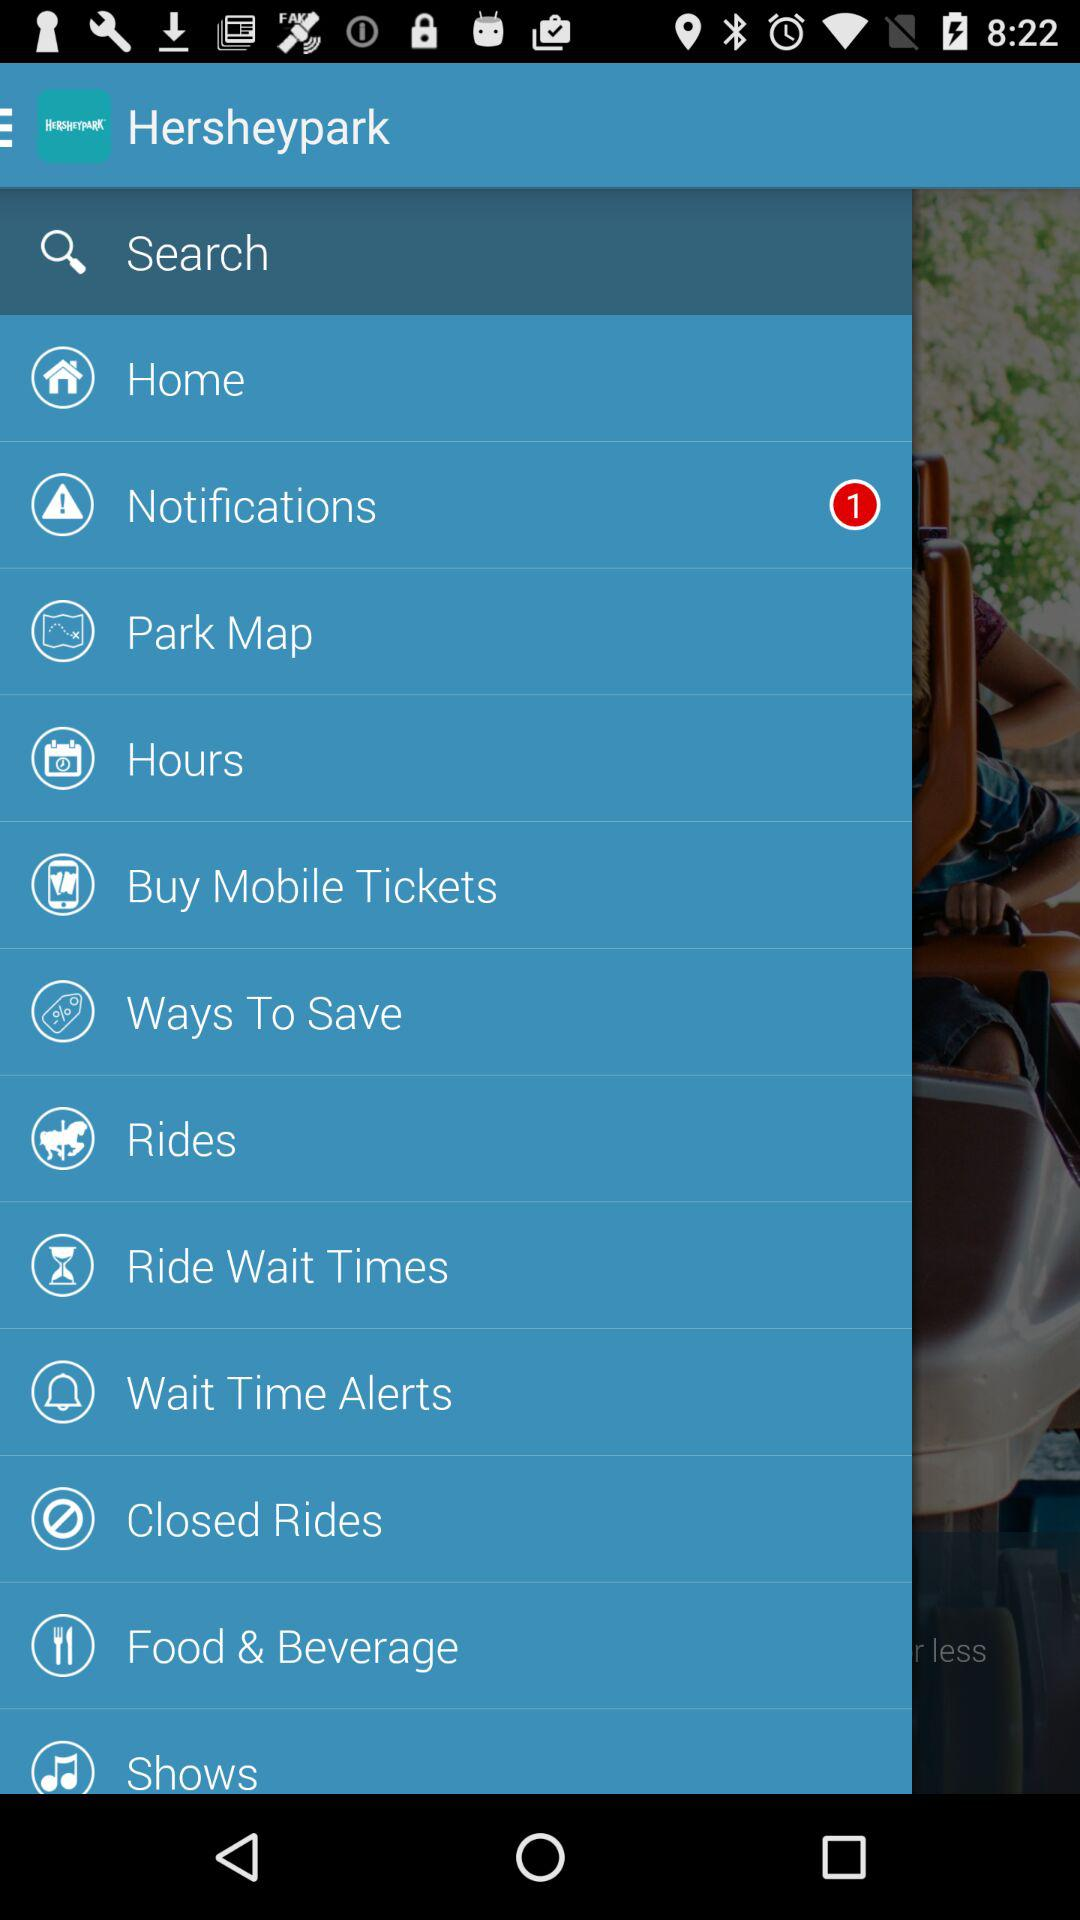Are there unread notifications?
When the provided information is insufficient, respond with <no answer>. <no answer> 